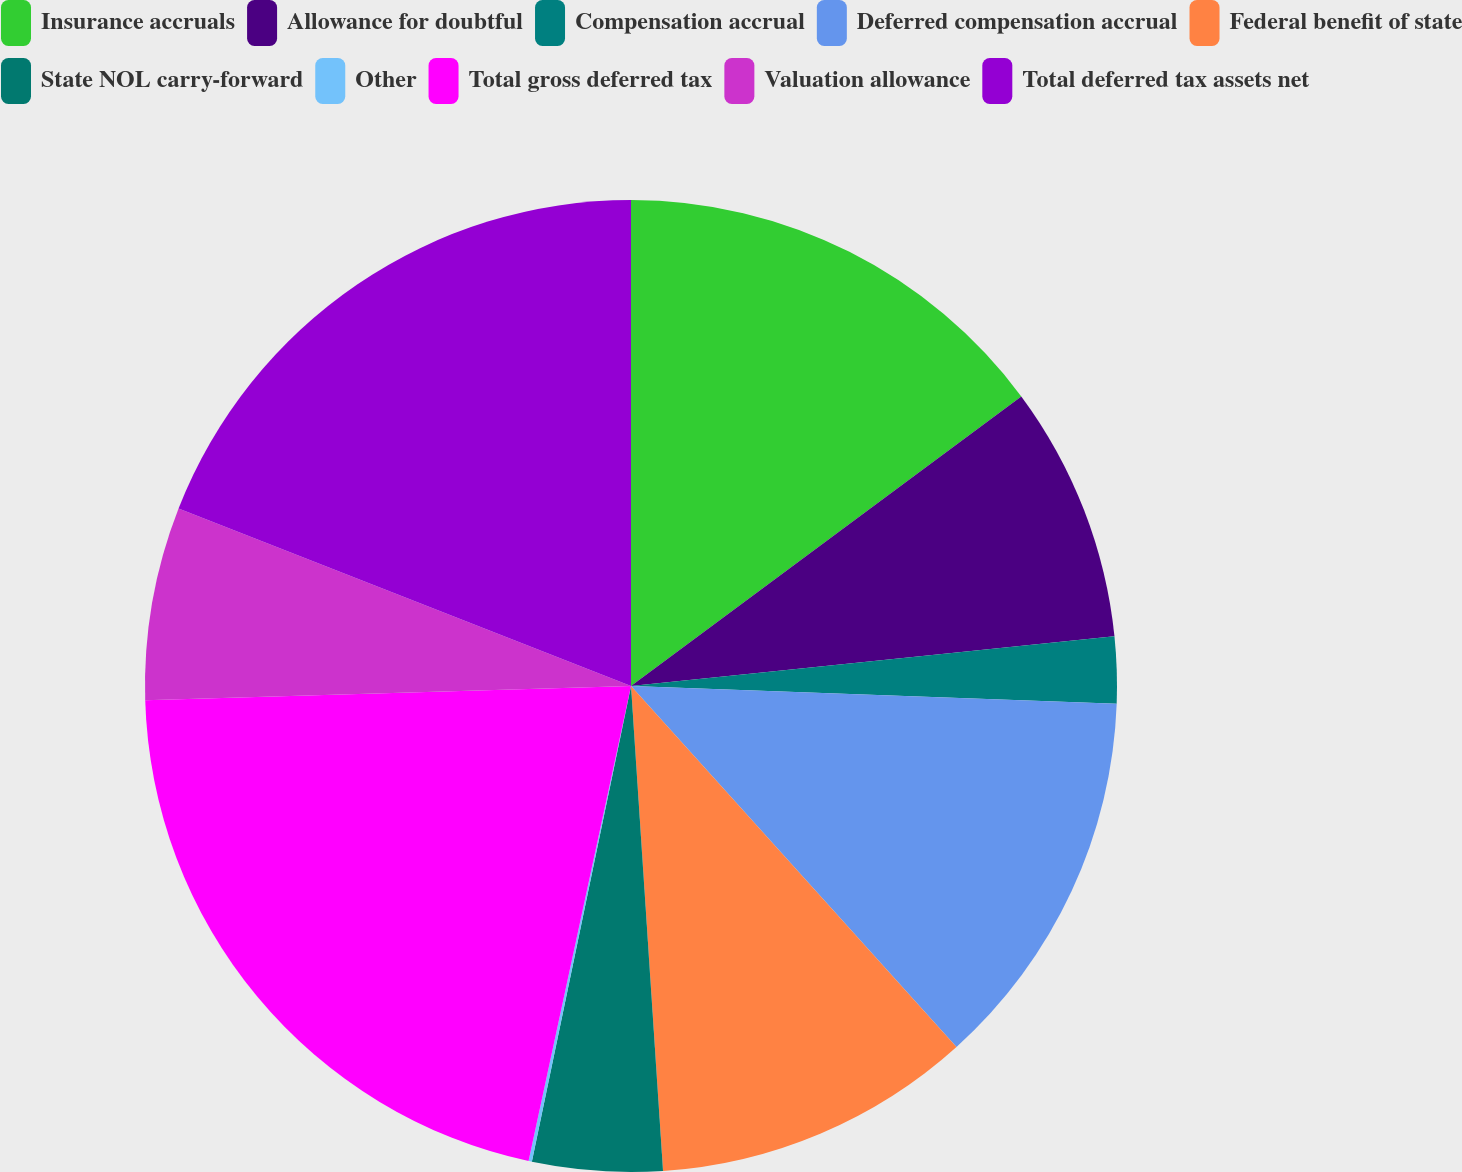Convert chart. <chart><loc_0><loc_0><loc_500><loc_500><pie_chart><fcel>Insurance accruals<fcel>Allowance for doubtful<fcel>Compensation accrual<fcel>Deferred compensation accrual<fcel>Federal benefit of state<fcel>State NOL carry-forward<fcel>Other<fcel>Total gross deferred tax<fcel>Valuation allowance<fcel>Total deferred tax assets net<nl><fcel>14.84%<fcel>8.53%<fcel>2.21%<fcel>12.74%<fcel>10.63%<fcel>4.32%<fcel>0.11%<fcel>21.15%<fcel>6.42%<fcel>19.05%<nl></chart> 